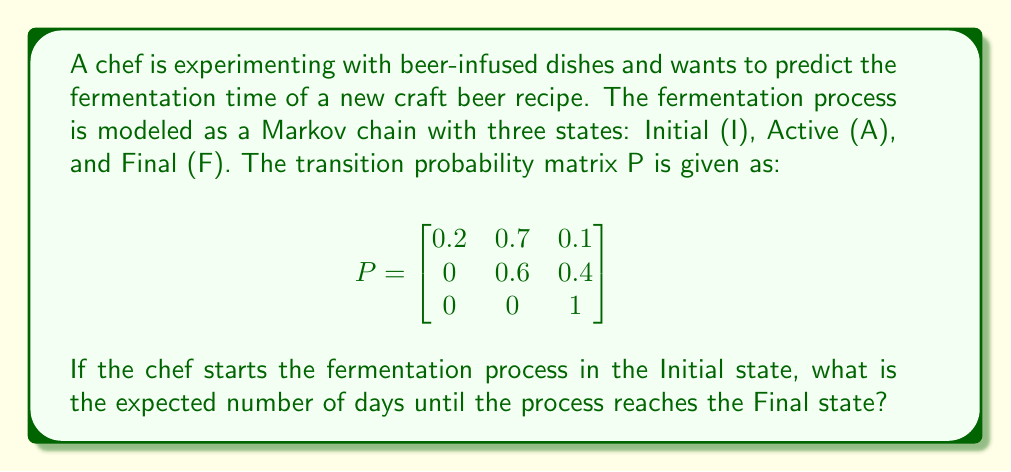Could you help me with this problem? To solve this problem, we'll use the concept of absorbing Markov chains and the fundamental matrix method:

1. Identify the absorbing state: Final (F) is the absorbing state.

2. Rewrite the transition matrix in canonical form:
   $$P = \begin{bmatrix}
   Q & R \\
   0 & I
   \end{bmatrix}$$
   
   Where Q represents the transition probabilities between transient states:
   $$Q = \begin{bmatrix}
   0.2 & 0.7 \\
   0 & 0.6
   \end{bmatrix}$$

3. Calculate the fundamental matrix N:
   $$N = (I - Q)^{-1}$$
   
   First, compute $I - Q$:
   $$I - Q = \begin{bmatrix}
   1 & 0 \\
   0 & 1
   \end{bmatrix} - \begin{bmatrix}
   0.2 & 0.7 \\
   0 & 0.6
   \end{bmatrix} = \begin{bmatrix}
   0.8 & -0.7 \\
   0 & 0.4
   \end{bmatrix}$$
   
   Now, find $(I - Q)^{-1}$:
   $$N = (I - Q)^{-1} = \begin{bmatrix}
   1.25 & 2.1875 \\
   0 & 2.5
   \end{bmatrix}$$

4. The expected number of steps (days) to absorption starting from each transient state is given by the sum of the corresponding row in N:

   From Initial state: $1.25 + 2.1875 = 3.4375$ days
   From Active state: $0 + 2.5 = 2.5$ days

5. Since the chef starts in the Initial state, the expected number of days until reaching the Final state is 3.4375 days.
Answer: 3.4375 days 